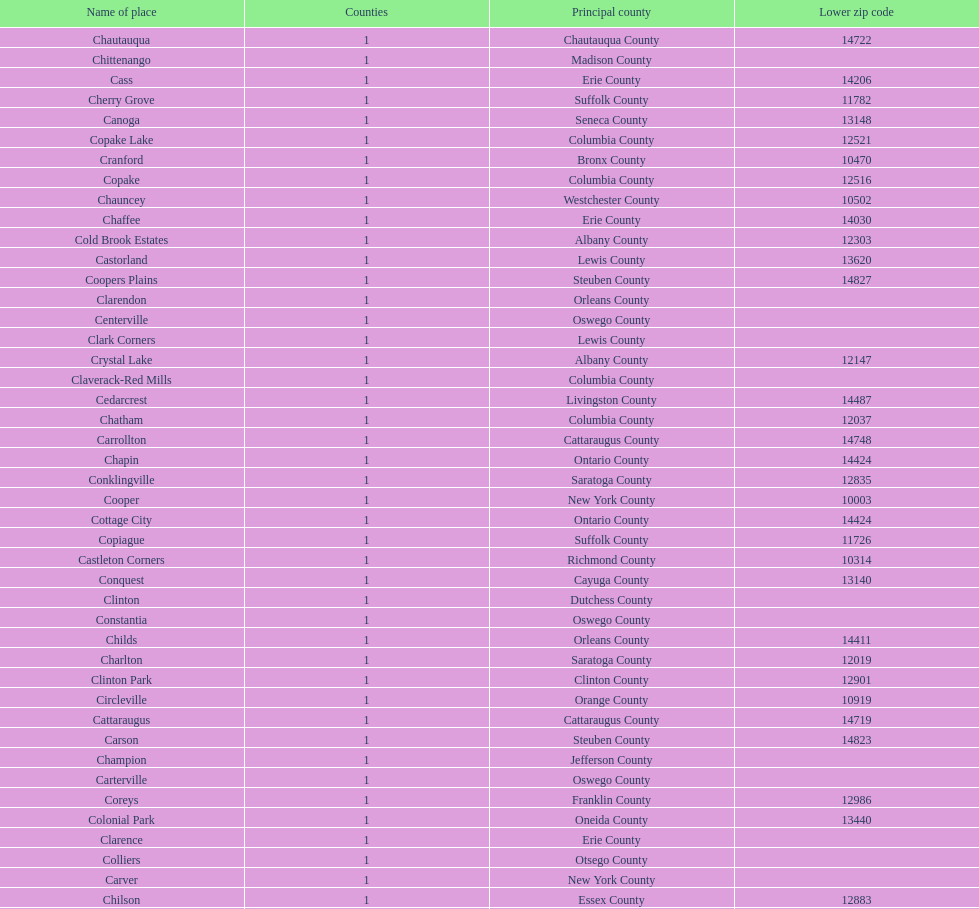How many total places are in greene county? 10. 